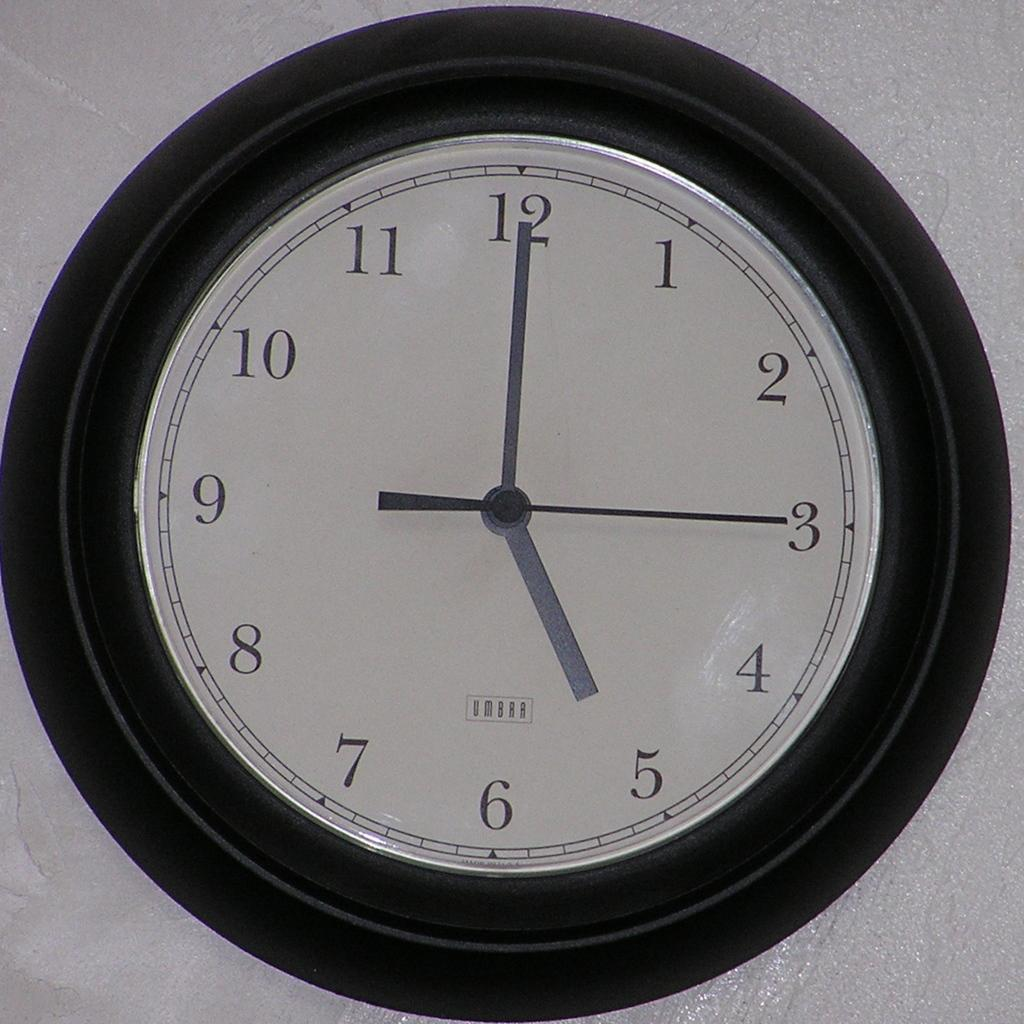<image>
Summarize the visual content of the image. The image displays black and white, circular, analog clock with the time 5:00 displayed 